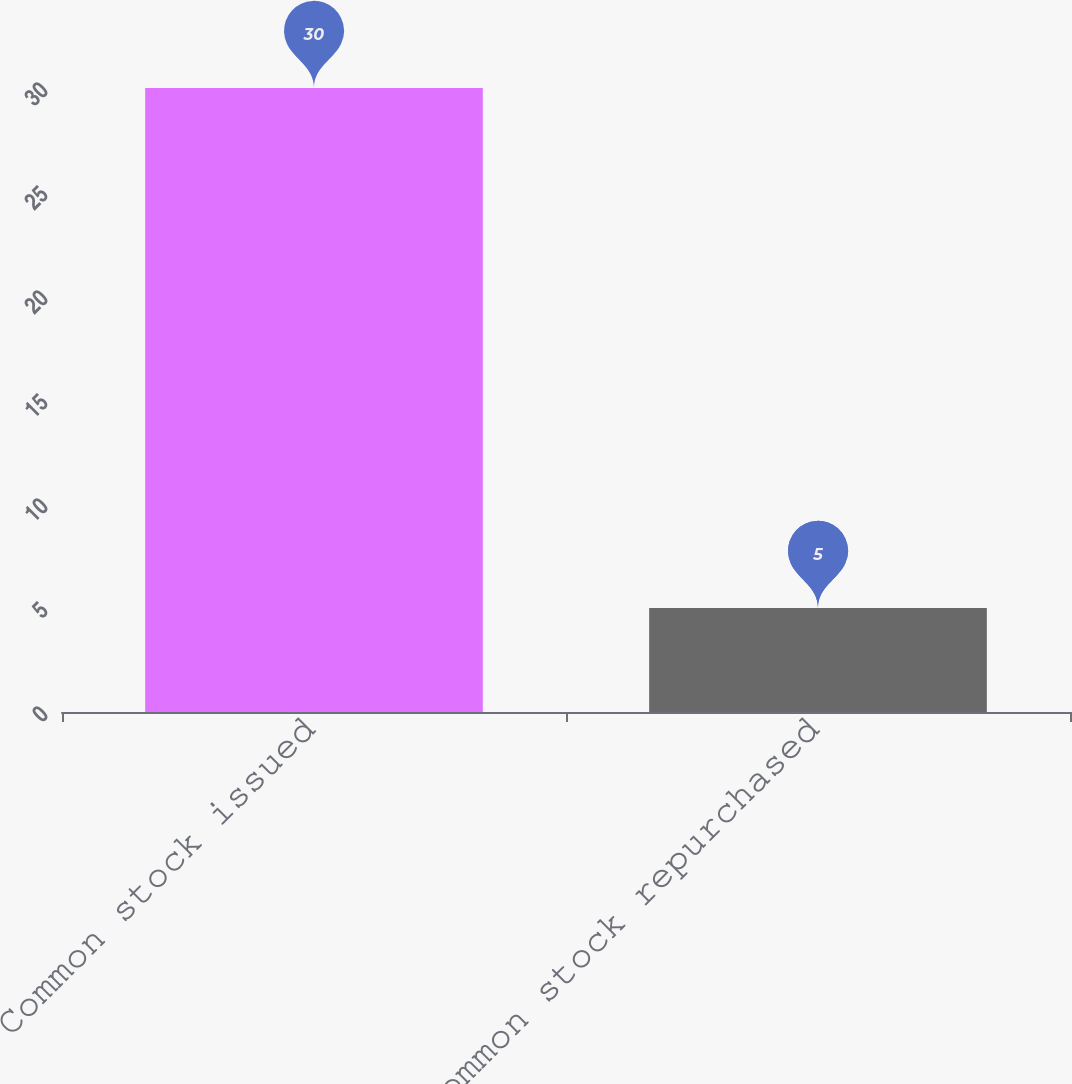<chart> <loc_0><loc_0><loc_500><loc_500><bar_chart><fcel>Common stock issued<fcel>Common stock repurchased<nl><fcel>30<fcel>5<nl></chart> 